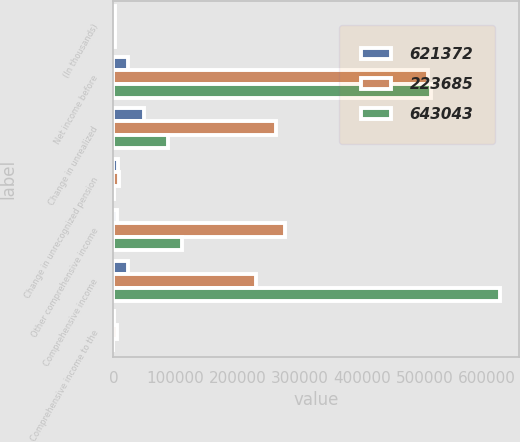Convert chart. <chart><loc_0><loc_0><loc_500><loc_500><stacked_bar_chart><ecel><fcel>(In thousands)<fcel>Net income before<fcel>Change in unrealized<fcel>Change in unrecognized pension<fcel>Other comprehensive income<fcel>Comprehensive income<fcel>Comprehensive income to the<nl><fcel>621372<fcel>2014<fcel>24205.5<fcel>49666<fcel>6651<fcel>5808<fcel>24205.5<fcel>752<nl><fcel>223685<fcel>2013<fcel>505301<fcel>261064<fcel>8700<fcel>276212<fcel>229089<fcel>5404<nl><fcel>643043<fcel>2012<fcel>510643<fcel>87316<fcel>1022<fcel>110857<fcel>621500<fcel>128<nl></chart> 